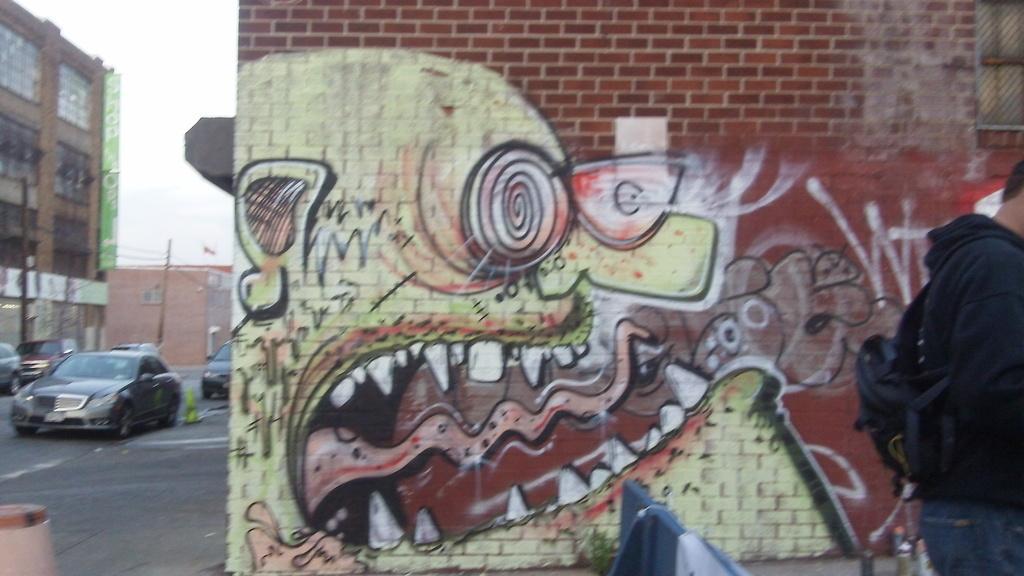Please provide a concise description of this image. There is a painting on this wall, on the left side few cars are moving on the road and there is a building on this image. On the right side there is a person, this person wore black color coat. 